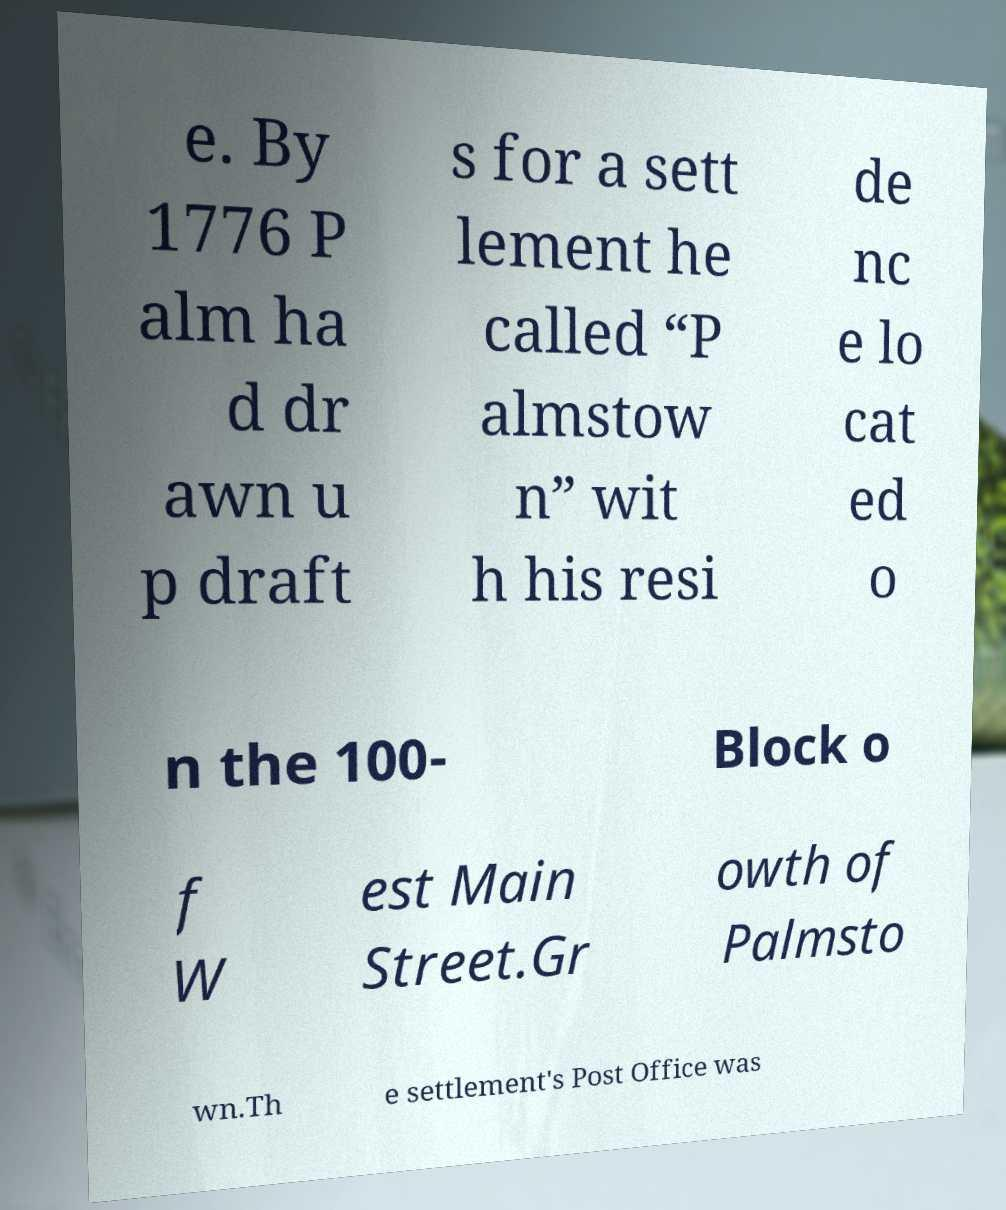Could you extract and type out the text from this image? e. By 1776 P alm ha d dr awn u p draft s for a sett lement he called “P almstow n” wit h his resi de nc e lo cat ed o n the 100- Block o f W est Main Street.Gr owth of Palmsto wn.Th e settlement's Post Office was 